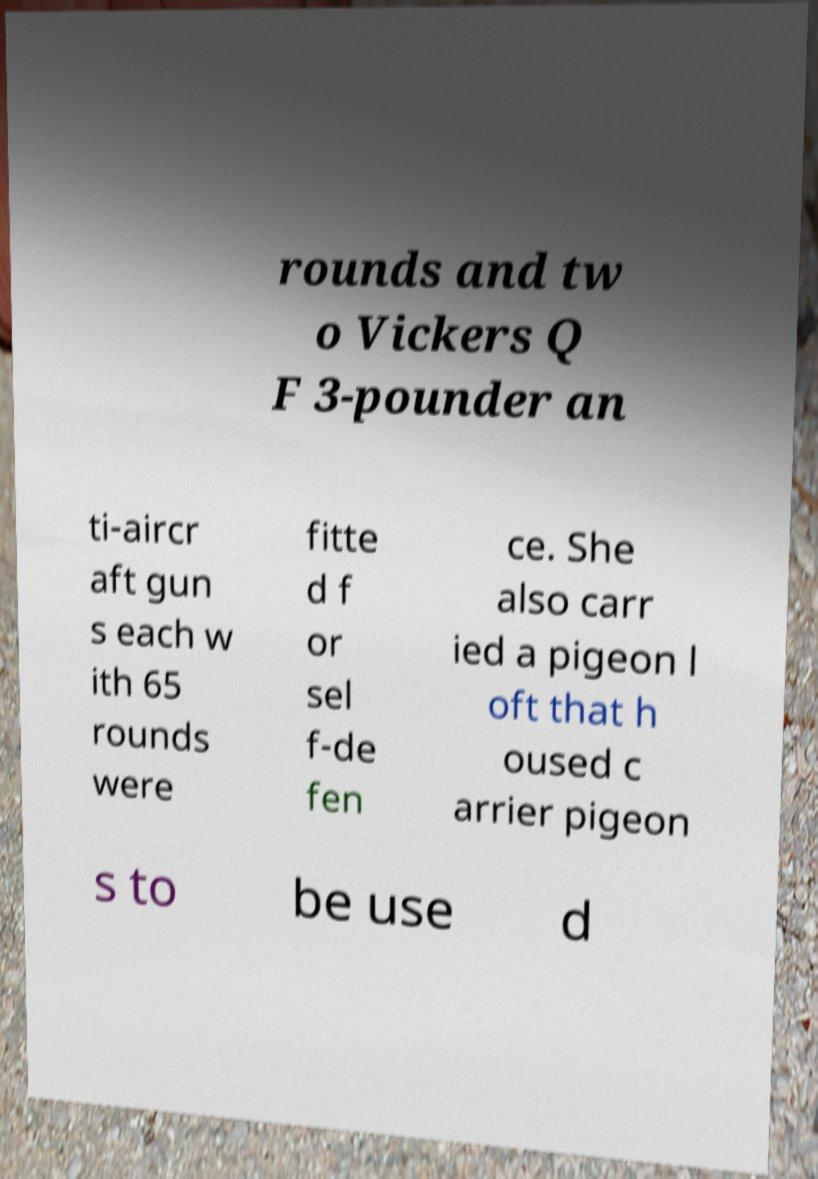I need the written content from this picture converted into text. Can you do that? rounds and tw o Vickers Q F 3-pounder an ti-aircr aft gun s each w ith 65 rounds were fitte d f or sel f-de fen ce. She also carr ied a pigeon l oft that h oused c arrier pigeon s to be use d 